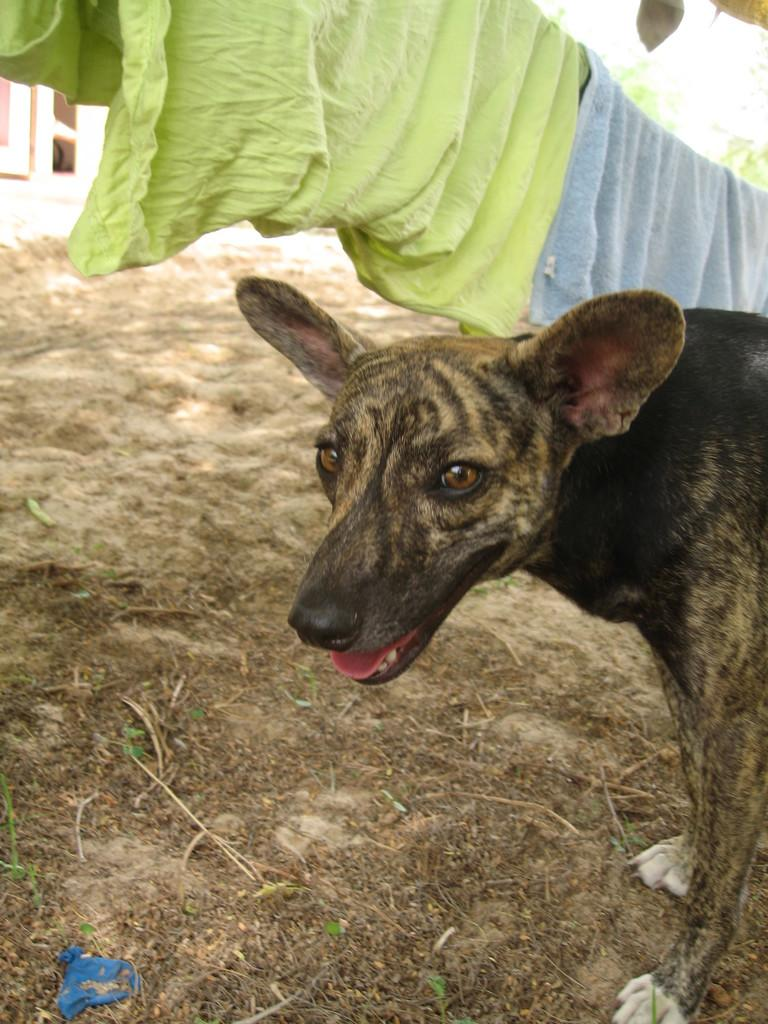What type of animal can be seen in the image? There is a dog in the image. What is hanging on the pole in the image? Clothes are hanging on a pole. What type of vegetation is visible at the bottom of the image? Grass is visible at the bottom of the image. What architectural feature is present in the background of the image? There is a window in the background near a wall. What type of chess piece is the dog holding in the image? There is no chess piece present in the image, and the dog is not holding anything. What is the dog's temper like in the image? The dog's temper cannot be determined from the image, as it is a static picture and does not convey emotions or behaviors. 